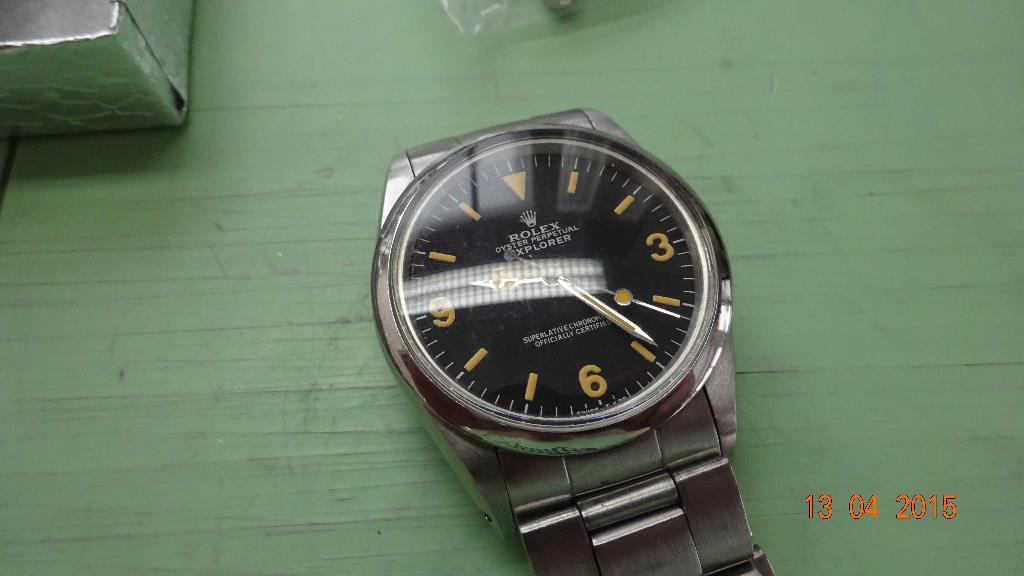<image>
Share a concise interpretation of the image provided. A silver or stainless watch with"Rolex Oyster Perpetual Explorer" written on it's face on a green wooden background. 